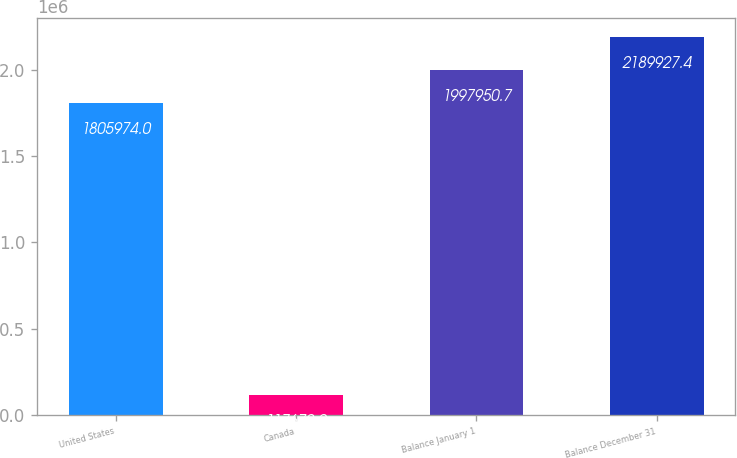<chart> <loc_0><loc_0><loc_500><loc_500><bar_chart><fcel>United States<fcel>Canada<fcel>Balance January 1<fcel>Balance December 31<nl><fcel>1.80597e+06<fcel>117672<fcel>1.99795e+06<fcel>2.18993e+06<nl></chart> 